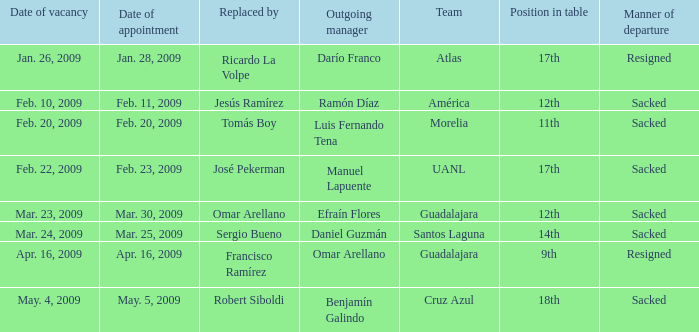What is Manner of Departure, when Outgoing Manager is "Luis Fernando Tena"? Sacked. Would you mind parsing the complete table? {'header': ['Date of vacancy', 'Date of appointment', 'Replaced by', 'Outgoing manager', 'Team', 'Position in table', 'Manner of departure'], 'rows': [['Jan. 26, 2009', 'Jan. 28, 2009', 'Ricardo La Volpe', 'Darío Franco', 'Atlas', '17th', 'Resigned'], ['Feb. 10, 2009', 'Feb. 11, 2009', 'Jesús Ramírez', 'Ramón Díaz', 'América', '12th', 'Sacked'], ['Feb. 20, 2009', 'Feb. 20, 2009', 'Tomás Boy', 'Luis Fernando Tena', 'Morelia', '11th', 'Sacked'], ['Feb. 22, 2009', 'Feb. 23, 2009', 'José Pekerman', 'Manuel Lapuente', 'UANL', '17th', 'Sacked'], ['Mar. 23, 2009', 'Mar. 30, 2009', 'Omar Arellano', 'Efraín Flores', 'Guadalajara', '12th', 'Sacked'], ['Mar. 24, 2009', 'Mar. 25, 2009', 'Sergio Bueno', 'Daniel Guzmán', 'Santos Laguna', '14th', 'Sacked'], ['Apr. 16, 2009', 'Apr. 16, 2009', 'Francisco Ramírez', 'Omar Arellano', 'Guadalajara', '9th', 'Resigned'], ['May. 4, 2009', 'May. 5, 2009', 'Robert Siboldi', 'Benjamín Galindo', 'Cruz Azul', '18th', 'Sacked']]} 